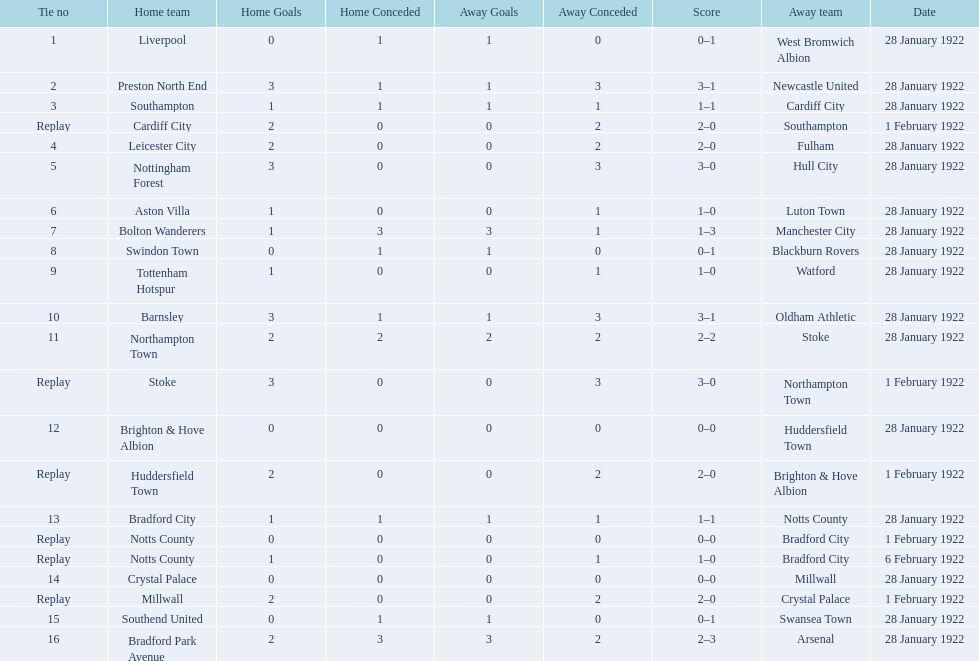What was the score in the aston villa game? 1–0. Which other team had an identical score? Tottenham Hotspur. 